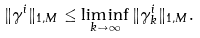Convert formula to latex. <formula><loc_0><loc_0><loc_500><loc_500>\| \gamma ^ { i } \| _ { 1 , M } \leq \liminf _ { k \to \infty } \| \gamma ^ { i } _ { k } \| _ { 1 , M } .</formula> 